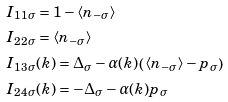Convert formula to latex. <formula><loc_0><loc_0><loc_500><loc_500>& I _ { 1 1 \sigma } = 1 - \langle n _ { - \sigma } \rangle \\ & I _ { 2 2 \sigma } = \langle n _ { - \sigma } \rangle \\ & I _ { 1 3 \sigma } ( { k } ) = \Delta _ { \sigma } - \alpha ( { k } ) \left ( \langle n _ { - \sigma } \rangle - p _ { \sigma } \right ) \\ & I _ { 2 4 \sigma } ( { k } ) = - \Delta _ { \sigma } - \alpha ( { k } ) p _ { \sigma }</formula> 